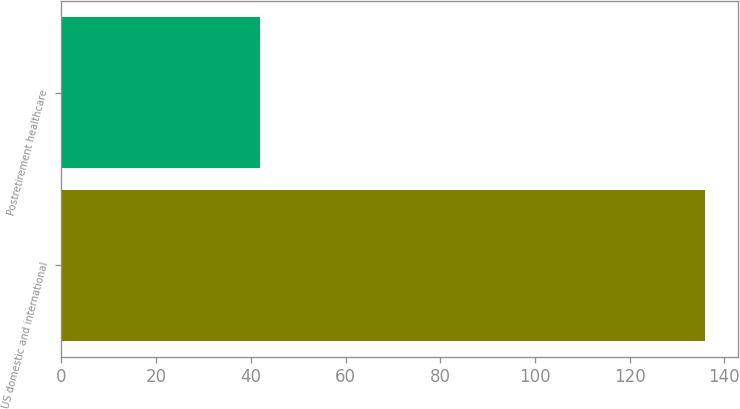Convert chart to OTSL. <chart><loc_0><loc_0><loc_500><loc_500><bar_chart><fcel>US domestic and international<fcel>Postretirement healthcare<nl><fcel>136<fcel>42<nl></chart> 